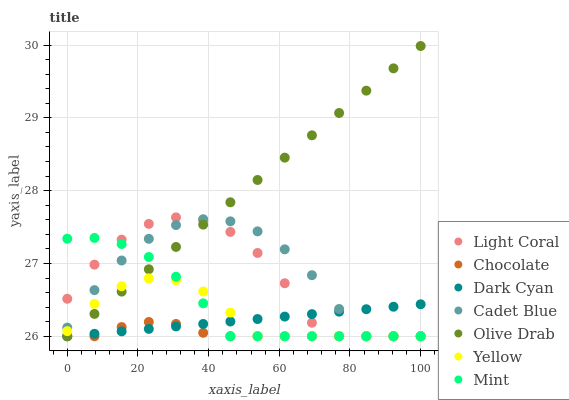Does Chocolate have the minimum area under the curve?
Answer yes or no. Yes. Does Olive Drab have the maximum area under the curve?
Answer yes or no. Yes. Does Yellow have the minimum area under the curve?
Answer yes or no. No. Does Yellow have the maximum area under the curve?
Answer yes or no. No. Is Dark Cyan the smoothest?
Answer yes or no. Yes. Is Light Coral the roughest?
Answer yes or no. Yes. Is Yellow the smoothest?
Answer yes or no. No. Is Yellow the roughest?
Answer yes or no. No. Does Cadet Blue have the lowest value?
Answer yes or no. Yes. Does Olive Drab have the highest value?
Answer yes or no. Yes. Does Yellow have the highest value?
Answer yes or no. No. Does Dark Cyan intersect Yellow?
Answer yes or no. Yes. Is Dark Cyan less than Yellow?
Answer yes or no. No. Is Dark Cyan greater than Yellow?
Answer yes or no. No. 